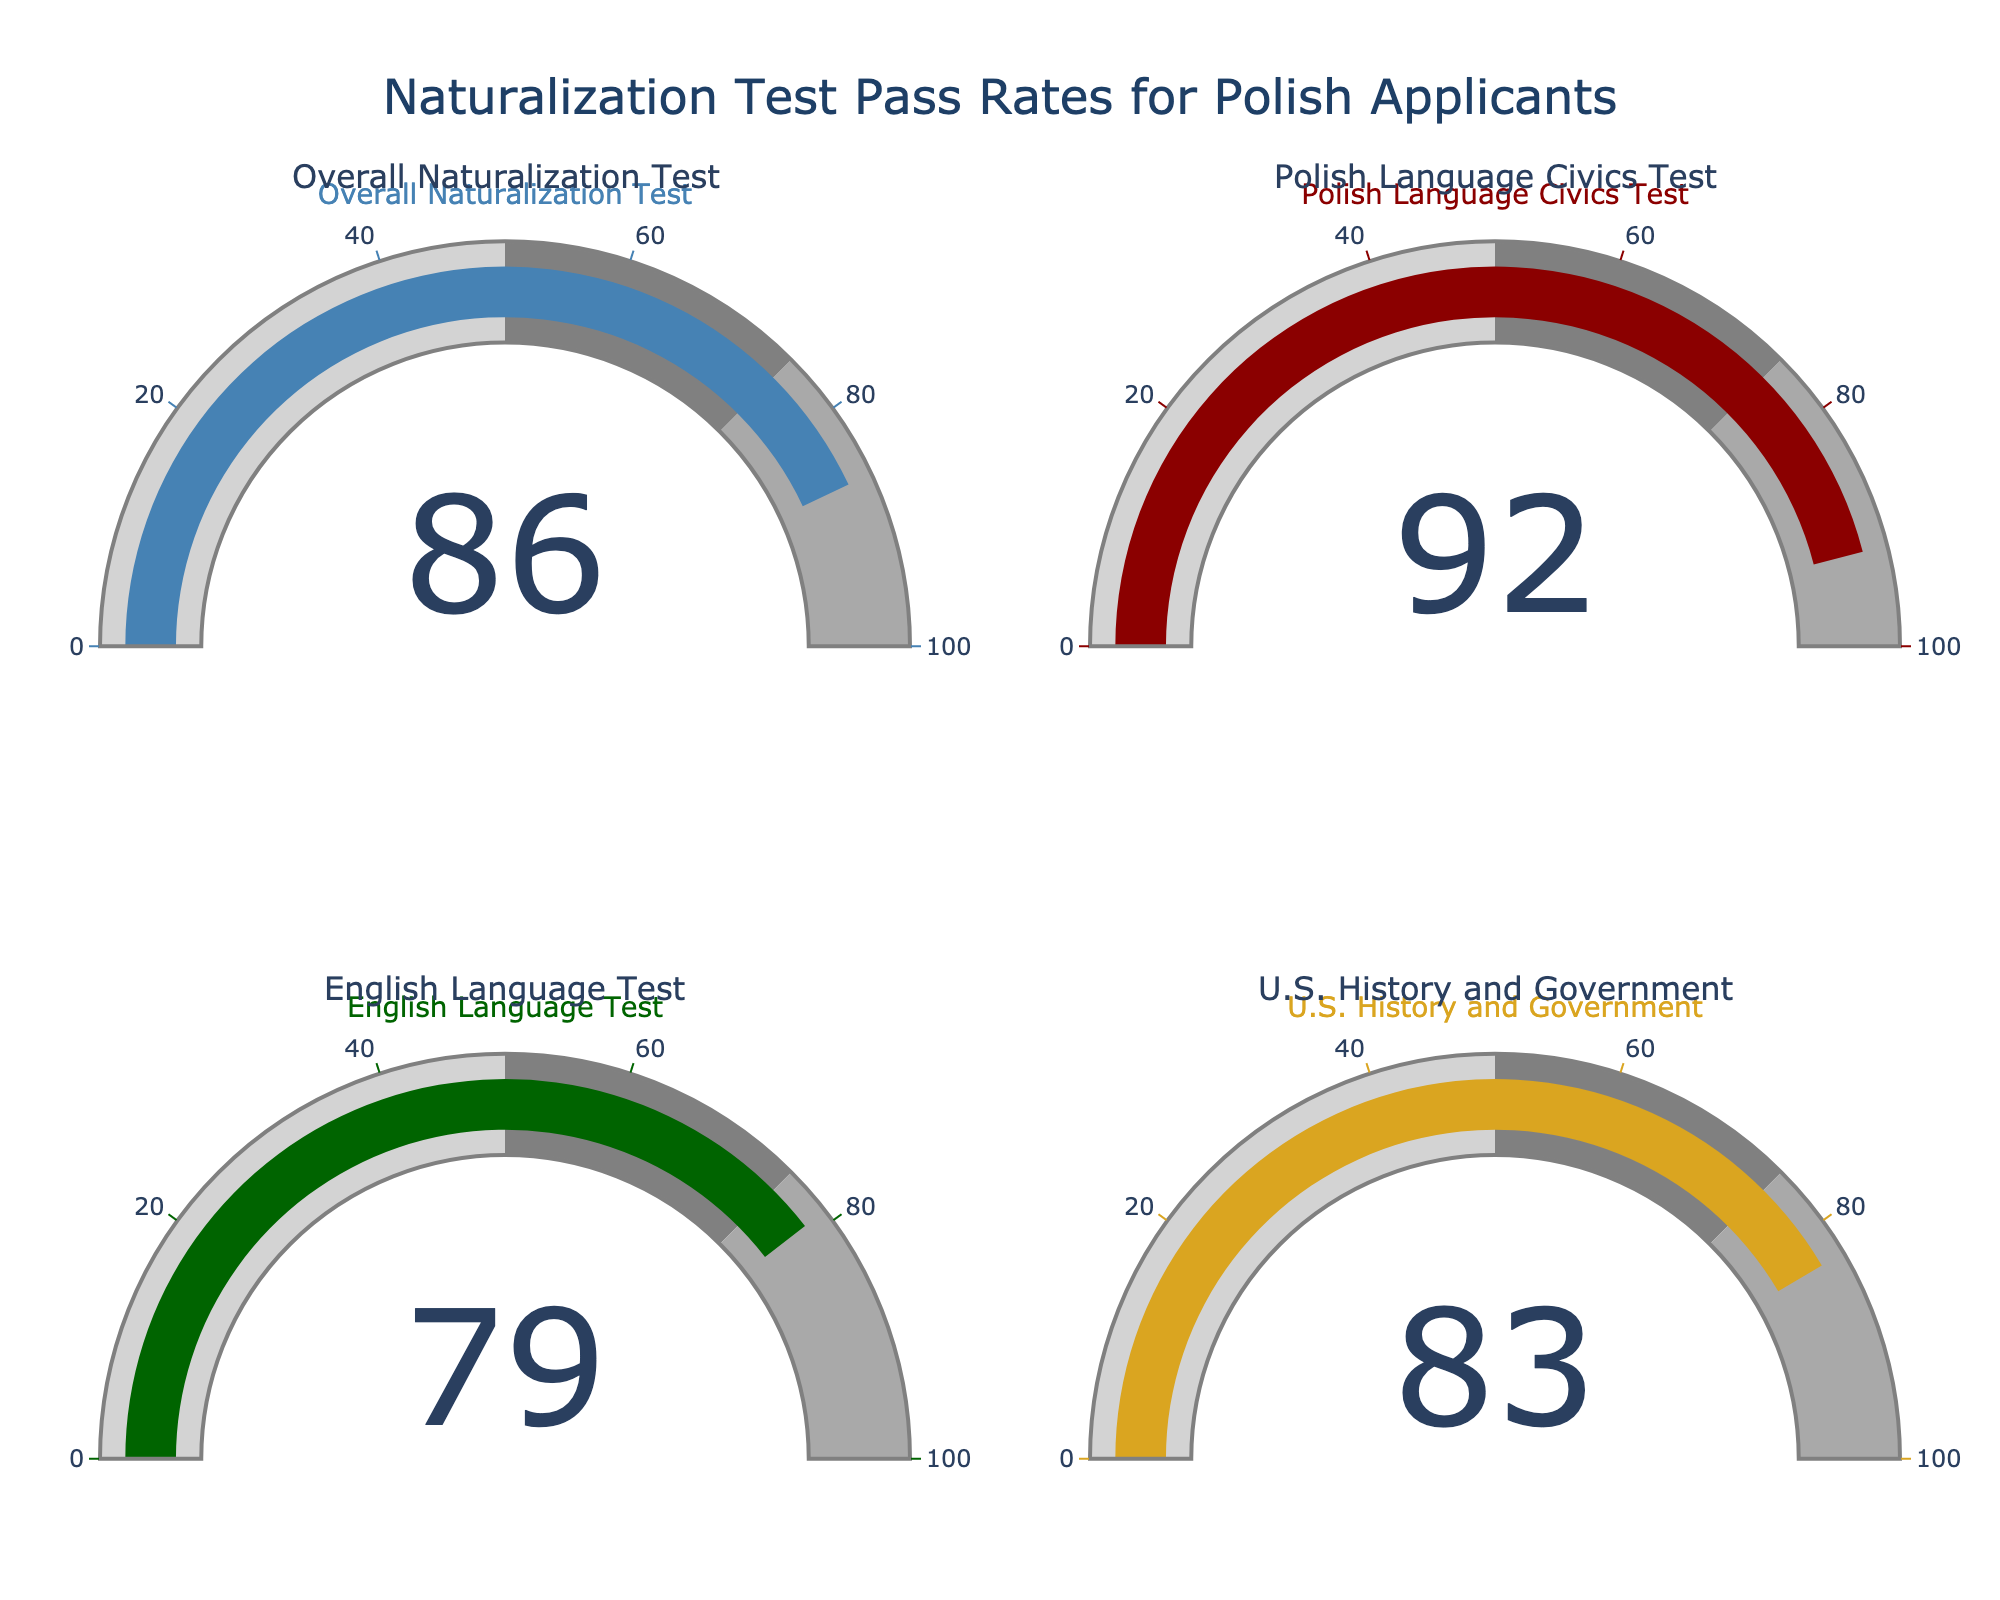What's the pass rate for the English Language Test? Look for the gauge labeled "English Language Test" and note the percentage shown
Answer: 79% What is the highest pass rate among the tests presented? Compare the pass rates for all tests: 86% (Overall Naturalization Test), 92% (Polish Language Civics Test), 79% (English Language Test), 83% (U.S. History and Government). The highest value is 92% for the Polish Language Civics Test
Answer: 92% Which test has the lowest pass rate? Compare the pass rates for all tests: 86% (Overall Naturalization Test), 92% (Polish Language Civics Test), 79% (English Language Test), 83% (U.S. History and Government). The lowest value is 79% for the English Language Test
Answer: English Language Test How much higher is the pass rate for the Polish Language Civics Test compared to the U.S. History and Government test? Subtract the pass rate of the U.S. History and Government test (83%) from that of the Polish Language Civics Test (92%): 92% - 83% = 9%
Answer: 9% What is the average pass rate of all the tests? Sum the pass rates for all tests: 86% + 92% + 79% + 83% = 340%. Divide by the number of tests (4) to get the average: 340% / 4 = 85%
Answer: 85% What is the difference between the highest and lowest pass rates? The highest pass rate is 92% (Polish Language Civics Test) and the lowest is 79% (English Language Test). Subtract the lowest from the highest: 92% - 79% = 13%
Answer: 13% Which test has a pass rate closest to the overall naturalization test pass rate? The overall naturalization test pass rate is 86%. Compare this to the other pass rates: Polish Language Civics Test (92%), English Language Test (79%), and U.S. History and Government (83%). The closest is the U.S. History and Government with 83%
Answer: U.S. History and Government What is the pass rate for the U.S. History and Government test? Look for the gauge labeled "U.S. History and Government" and note the percentage shown
Answer: 83% By how much does the pass rate for the Polish Language Civics Test exceed the average pass rate of all tests? Calculate the average pass rate of all tests (85%). Subtract this average from the Polish Language Civics Test pass rate (92%): 92% - 85% = 7%
Answer: 7% What do the colors in the gauges represent? The colors in the gauges (light gray, gray, dark gray) likely represent different ranges of performance, with darker shades indicating higher performance. Example: dark gray represents pass rates from 75% to 100%
Answer: Performance ranges 